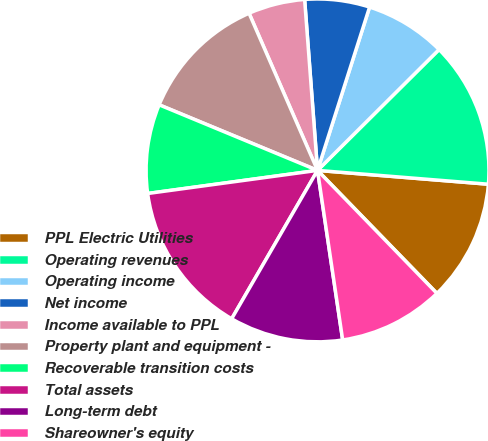Convert chart to OTSL. <chart><loc_0><loc_0><loc_500><loc_500><pie_chart><fcel>PPL Electric Utilities<fcel>Operating revenues<fcel>Operating income<fcel>Net income<fcel>Income available to PPL<fcel>Property plant and equipment -<fcel>Recoverable transition costs<fcel>Total assets<fcel>Long-term debt<fcel>Shareowner's equity<nl><fcel>11.45%<fcel>13.74%<fcel>7.63%<fcel>6.11%<fcel>5.34%<fcel>12.21%<fcel>8.4%<fcel>14.5%<fcel>10.69%<fcel>9.92%<nl></chart> 